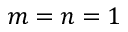<formula> <loc_0><loc_0><loc_500><loc_500>m = n = 1</formula> 